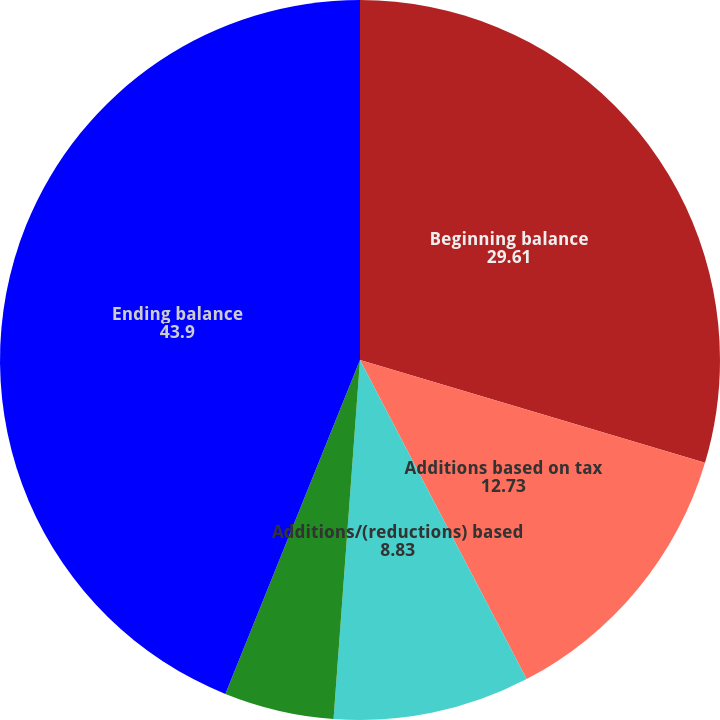<chart> <loc_0><loc_0><loc_500><loc_500><pie_chart><fcel>Beginning balance<fcel>Additions based on tax<fcel>Additions/(reductions) based<fcel>Reductions due to lapse of<fcel>Ending balance<nl><fcel>29.61%<fcel>12.73%<fcel>8.83%<fcel>4.93%<fcel>43.9%<nl></chart> 